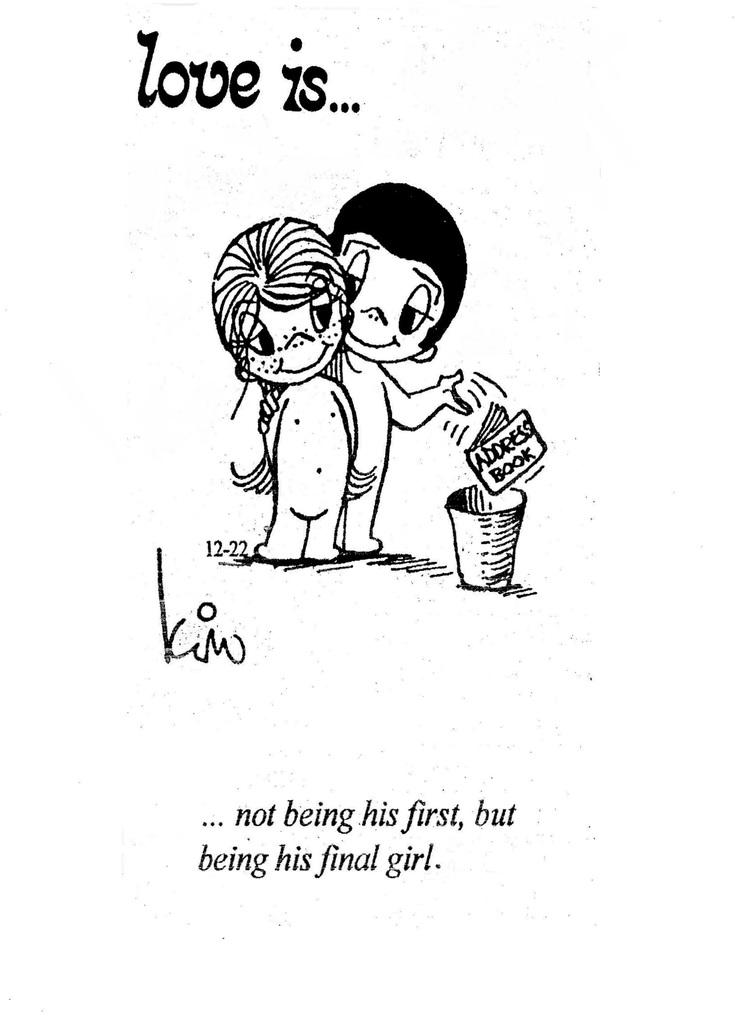What type of content can be found in the image? There is some text and numbers in the image. How many individuals are present in the image? There are two people in the image. What objects can be seen in the image besides the people? There is a book and a dustbin in the image. What type of box is being used for reading in the image? There is no box or reading activity present in the image. How many letters are visible on the book in the image? There is no information about the number of letters on the book in the image, as the focus is on the presence of the book itself. 